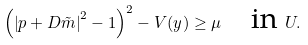<formula> <loc_0><loc_0><loc_500><loc_500>\left ( \left | p + D \tilde { m } \right | ^ { 2 } - 1 \right ) ^ { 2 } - V ( y ) \geq \mu \quad \text {in} \ U .</formula> 